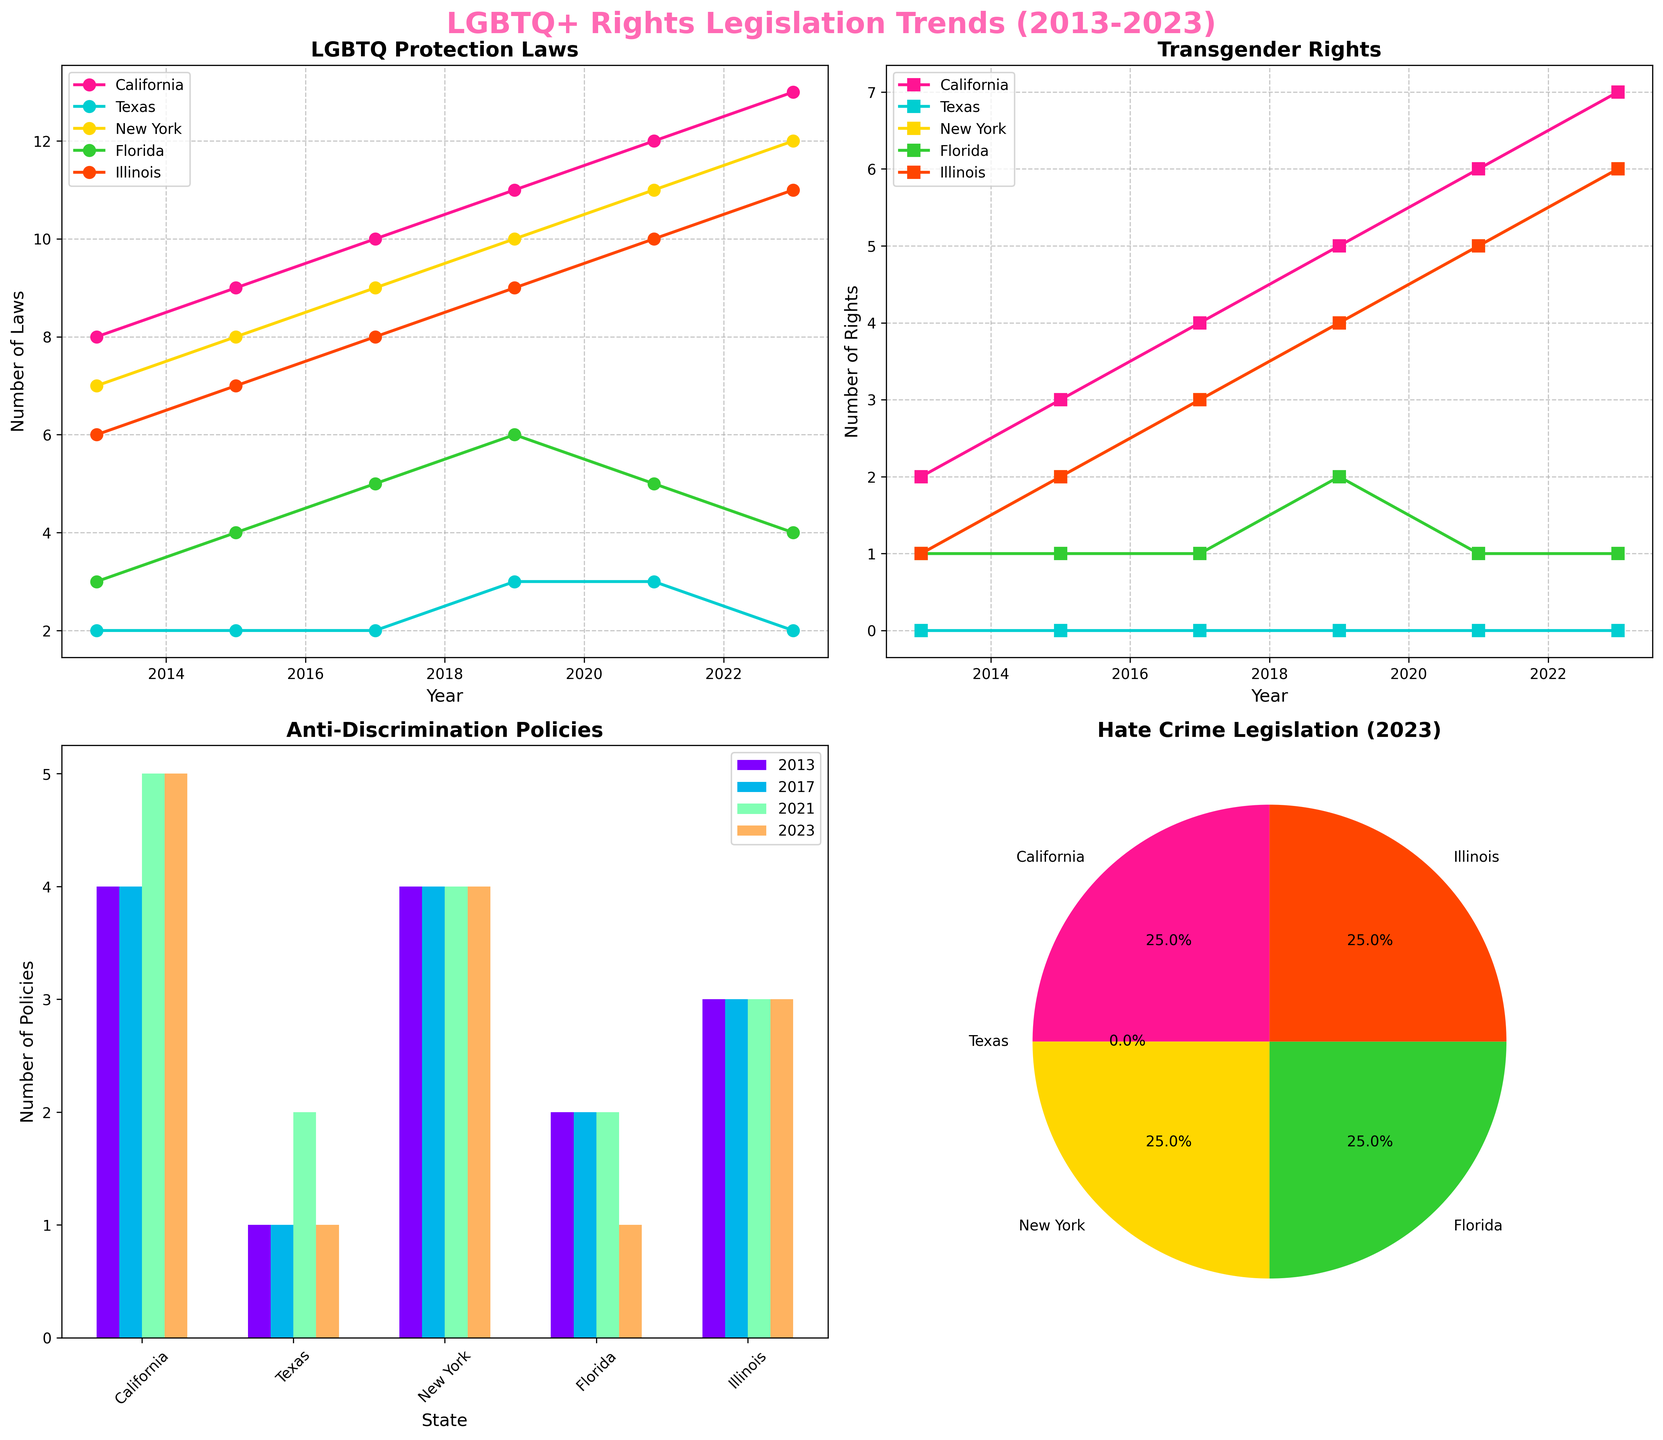What state had the highest number of LGBTQ protection laws in 2023? Look at the "LGBTQ Protection Laws" plot. The line for California is the highest at 13 in 2023.
Answer: California Which state showed no improvement in transgender rights over the decade? Check the "Transgender Rights" plot. Texas maintained a value of 0 throughout the decade.
Answer: Texas How did Florida's anti-discrimination policies change from 2013 to 2023? Refer to the "Anti-Discrimination Policies" bar chart and compare the bars for Florida between 2013 and 2023. It went from 2 in 2013 to 1 in 2023.
Answer: Decreased Which state had consistent values in hate crime legislation across the decade? Look at the pie chart for 2023 and cross-check with the data points in the other years. California is consistently at 1 in hate crime legislation.
Answer: California By how much did Illinois’s transgender rights increase from 2013 to 2023? Find Illinois in the "Transgender Rights" plot. In 2013 it was 1 and increased to 6 in 2023. So, the increase is 6 - 1 = 5.
Answer: 5 Which year shows the biggest leap in LGBTQ protection laws for New York? Use the "LGBTQ Protection Laws" plot and observe New York's line. The largest increase is from 2013 to 2015, going from 7 to 8.
Answer: 2015 Compare the number of anti-discrimination policies between Texas and Florida in 2017. Which state had more? Refer to the "Anti-Discrimination Policies" bar chart for 2017. Texas has 1 while Florida has 2.
Answer: Florida What percentage of the hate crime legislation in 2023 is attributed to New York? Look at the pie chart for 2023. New York has 1 law, out of a total sum of 4+1+6+1+1 or 13 (as shown by the sizes), which is 100/13 or roughly 8.3%.
Answer: 8.3% Which state had the lowest number of LGBTQ protection laws in 2019? Check the "LGBTQ Protection Laws" plot and look for the lowest point in 2019. Texas had the lowest at 3.
Answer: Texas How many total anti-discrimination policies were there across all highlighted states in 2021? Sum the values from the "Anti-Discrimination Policies" bar chart for 2021 (California: 5, Texas: 2, New York: 4, Florida: 2, Illinois: 3). The total is 5 + 2 + 4 + 2 + 3 = 16.
Answer: 16 